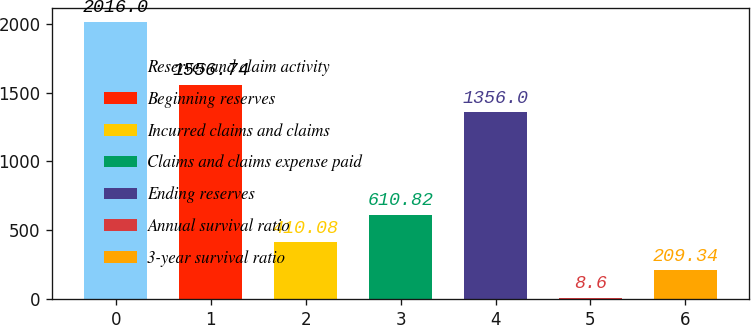<chart> <loc_0><loc_0><loc_500><loc_500><bar_chart><fcel>Reserves and claim activity<fcel>Beginning reserves<fcel>Incurred claims and claims<fcel>Claims and claims expense paid<fcel>Ending reserves<fcel>Annual survival ratio<fcel>3-year survival ratio<nl><fcel>2016<fcel>1556.74<fcel>410.08<fcel>610.82<fcel>1356<fcel>8.6<fcel>209.34<nl></chart> 